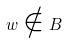<formula> <loc_0><loc_0><loc_500><loc_500>w \notin B</formula> 